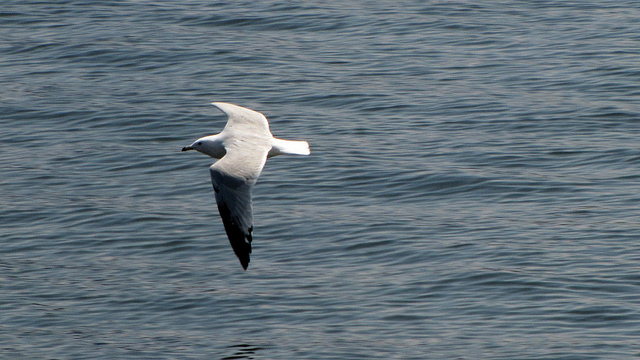<image>What kind of birds are in the water? I am not sure what kind of birds are in the water. It could possibly be seagulls. Are the birds in calm or rough waters? I can't quite tell if the birds are in calm or rough waters, but it seems to lean more towards calm waters. What kind of birds are in the water? I don't know what kind of birds are in the water. It can be seagulls. Are the birds in calm or rough waters? It is unknown if the birds are in calm or rough waters. 